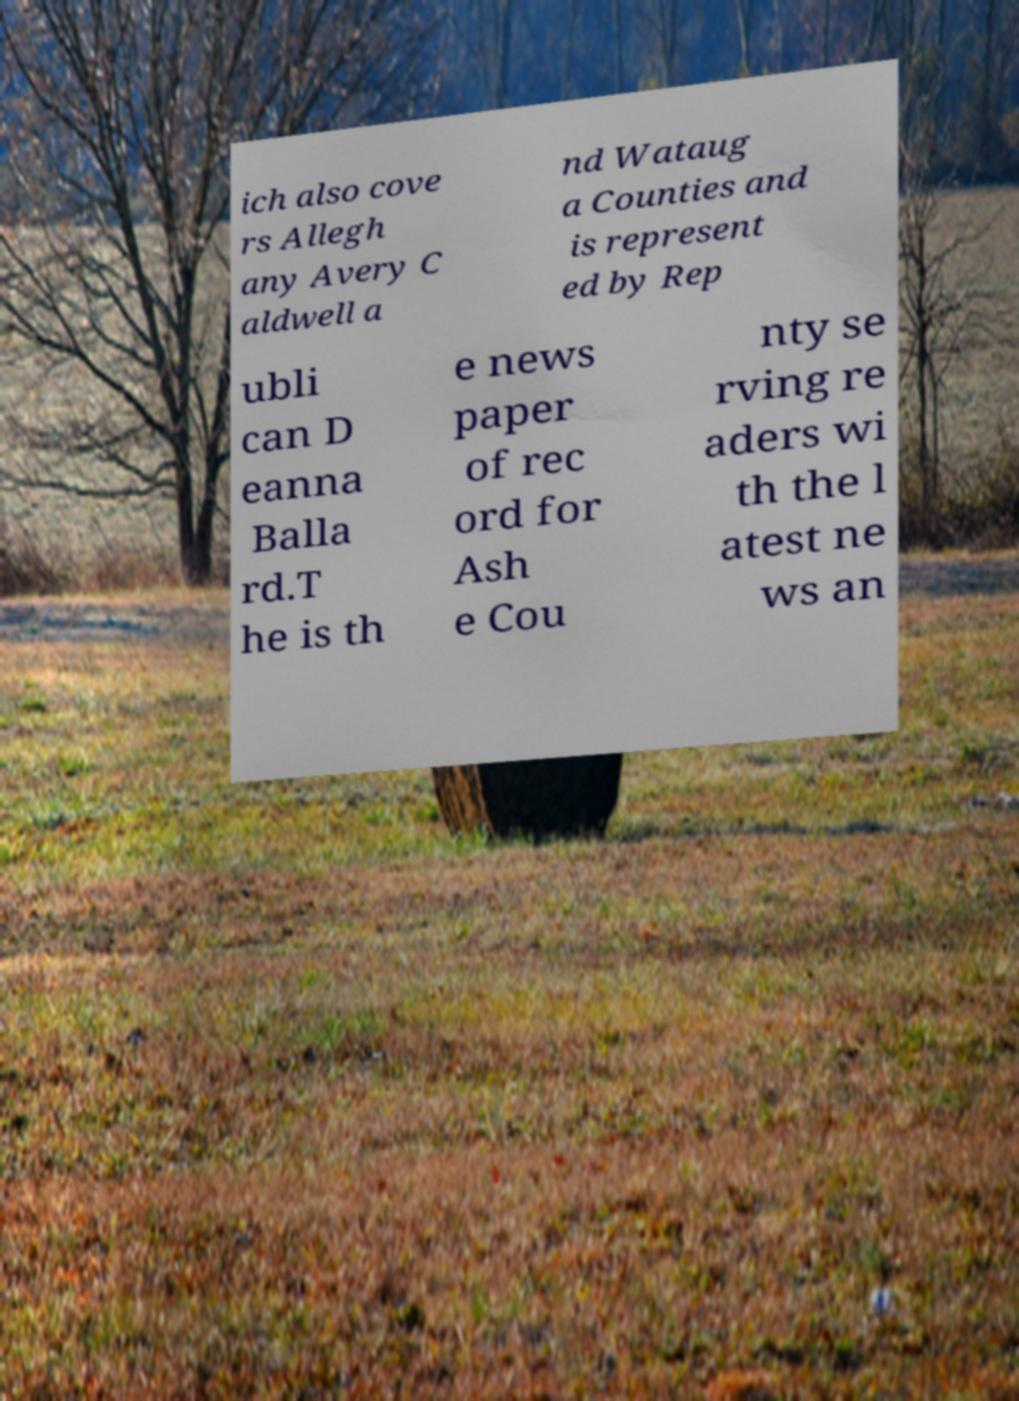Please read and relay the text visible in this image. What does it say? ich also cove rs Allegh any Avery C aldwell a nd Wataug a Counties and is represent ed by Rep ubli can D eanna Balla rd.T he is th e news paper of rec ord for Ash e Cou nty se rving re aders wi th the l atest ne ws an 